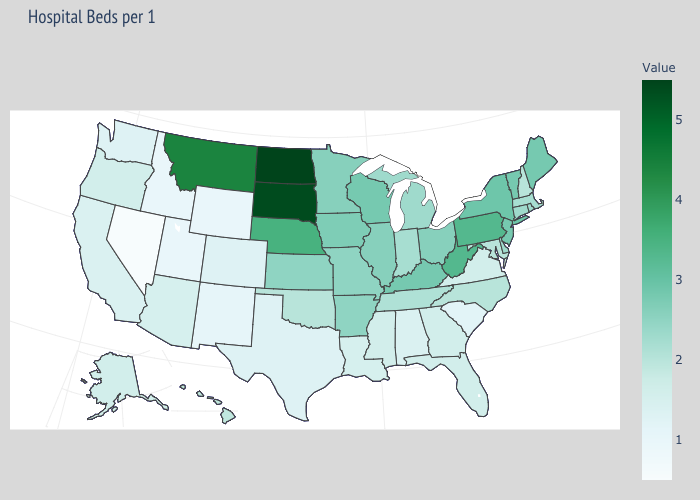Is the legend a continuous bar?
Write a very short answer. Yes. Among the states that border Delaware , which have the highest value?
Concise answer only. Pennsylvania. Among the states that border Nevada , does Oregon have the highest value?
Write a very short answer. Yes. Is the legend a continuous bar?
Quick response, please. Yes. 